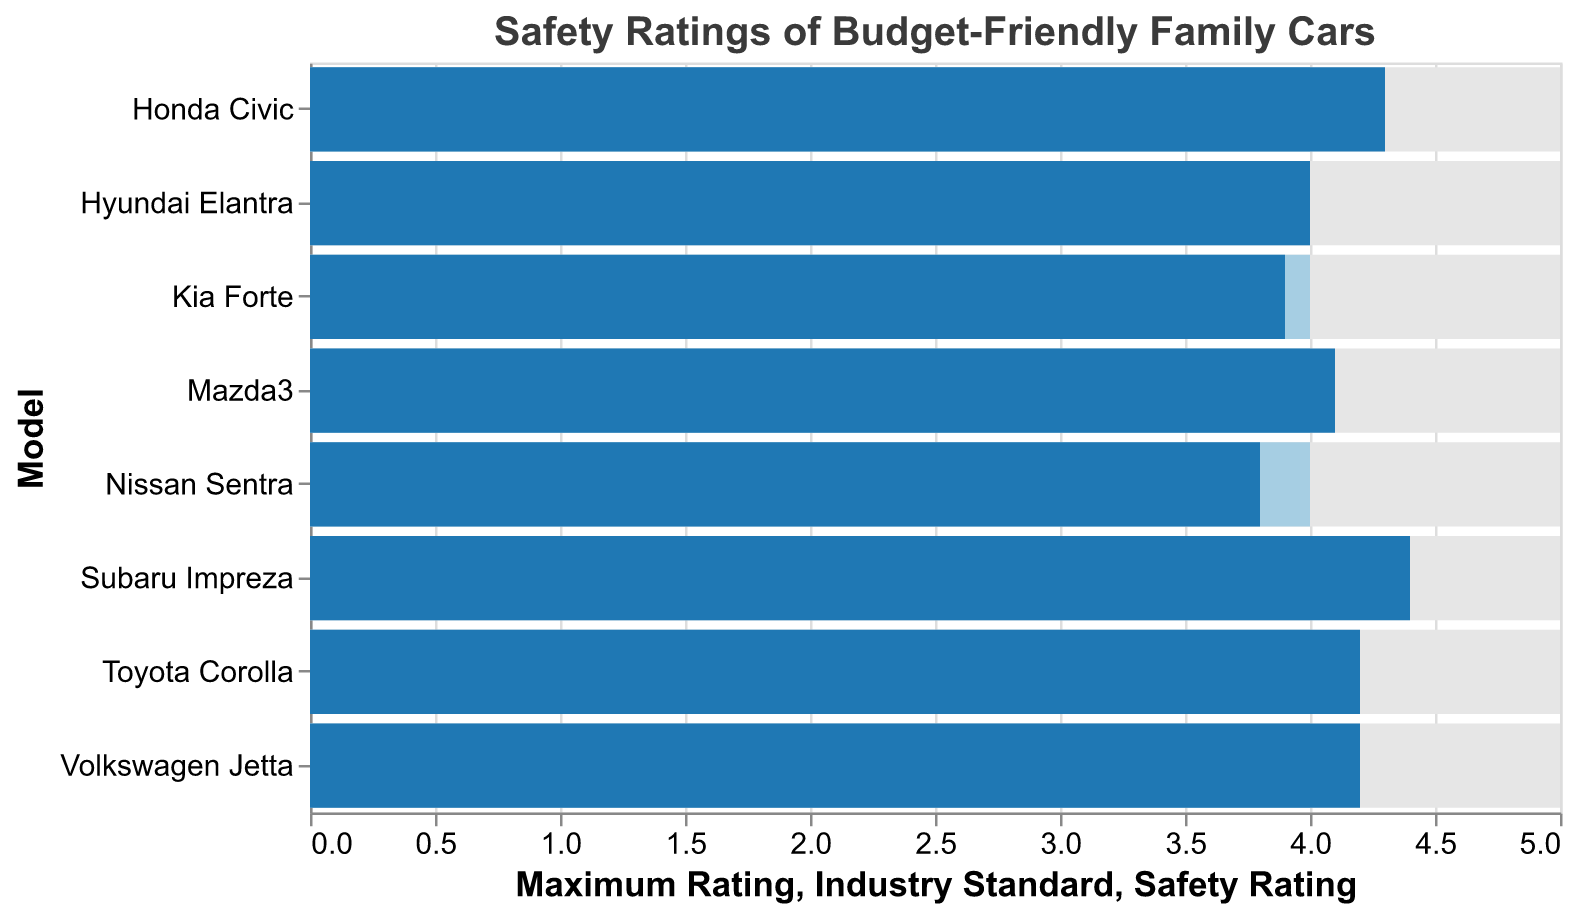What's the maximum safety rating achievable for these family cars? The maximum safety rating is indicated by the light grey bar, which reaches up to 5.
Answer: 5 Which car has the highest safety rating? The Subaru Impreza has the highest safety rating of 4.4, as indicated by the longest dark blue bar.
Answer: Subaru Impreza Which car has a safety rating equal to the industry standard? The Hyundai Elantra has a safety rating of 4.0, equal to the industry standard.
Answer: Hyundai Elantra How many cars have a safety rating above the industry standard? By observing the dark blue bars that extend beyond the light blue bars, you can see that 5 cars (Toyota Corolla, Honda Civic, Mazda3, Volkswagen Jetta, and Subaru Impreza) have safety ratings above the industry standard of 4.0.
Answer: 5 Which cars have a safety rating below the industry standard? By looking at the dark blue bars that are shorter than the light blue bars, you can see that the Kia Forte and Nissan Sentra have safety ratings below the industry standard of 4.0.
Answer: Kia Forte, Nissan Sentra What is the gap between the highest and lowest safety ratings? The highest safety rating is 4.4 (Subaru Impreza) and the lowest is 3.8 (Nissan Sentra). The gap is 4.4 - 3.8 = 0.6.
Answer: 0.6 Which car is just at the industry standard for safety ratings? The Hyundai Elantra has a safety rating of 4.0, which matches the industry standard.
Answer: Hyundai Elantra What is the average safety rating of all the cars? Sum all the safety ratings (4.2 + 4.3 + 4.1 + 4.0 + 3.9 + 4.2 + 4.4 + 3.8 = 32.9) and divide by the number of cars (8). The average is 32.9 / 8 = 4.1125.
Answer: 4.1125 How does the Volkswagen Jetta compare to the industry standard? The Volkswagen Jetta has a safety rating of 4.2, which is 0.2 higher than the industry standard of 4.0.
Answer: 0.2 higher Which cars have safety ratings that are exactly aligned with the industry's maximum safety rating? None of the cars have a safety rating that matches the industry's maximum rating of 5.
Answer: None 